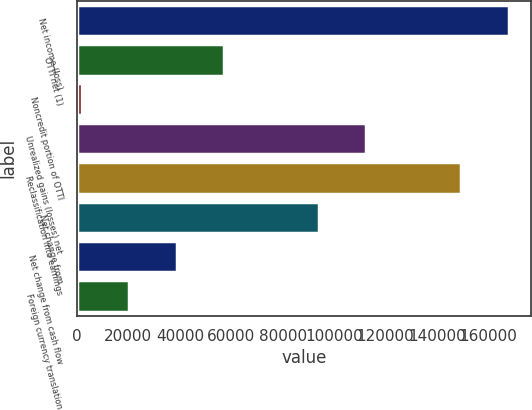Convert chart. <chart><loc_0><loc_0><loc_500><loc_500><bar_chart><fcel>Net income (loss)<fcel>OTTI net (1)<fcel>Noncredit portion of OTTI<fcel>Unrealized gains (losses) net<fcel>Reclassification into earnings<fcel>Net change from<fcel>Net change from cash flow<fcel>Foreign currency translation<nl><fcel>167898<fcel>57194.5<fcel>1843<fcel>112546<fcel>149447<fcel>94095.5<fcel>38744<fcel>20293.5<nl></chart> 